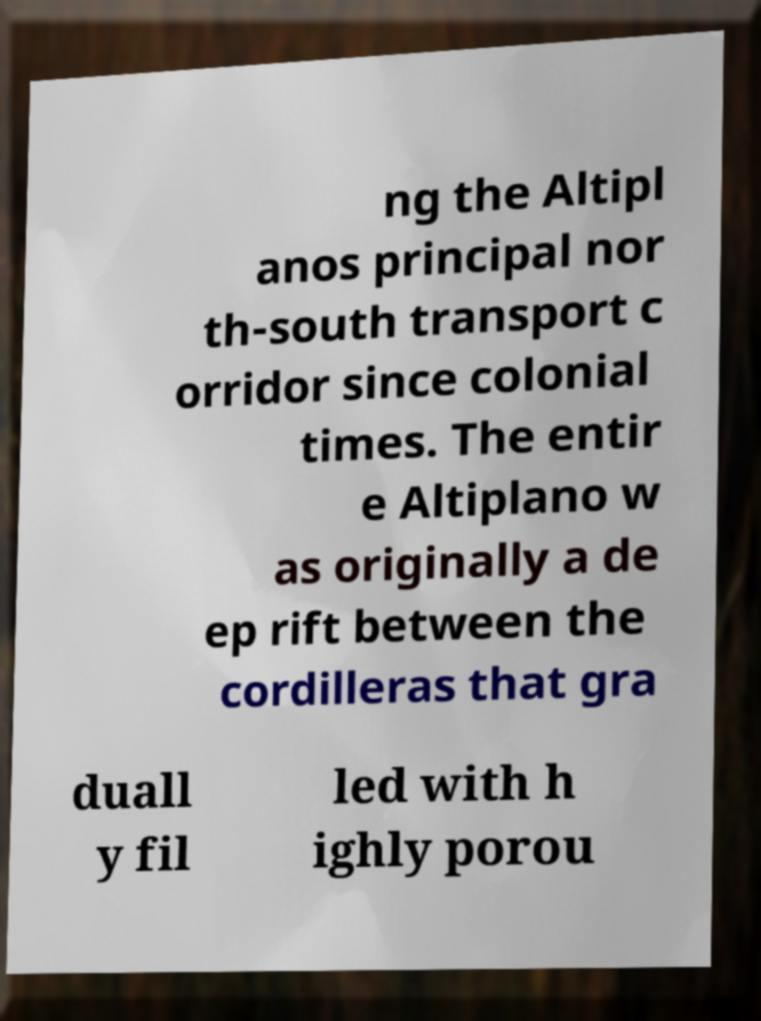Can you read and provide the text displayed in the image?This photo seems to have some interesting text. Can you extract and type it out for me? ng the Altipl anos principal nor th-south transport c orridor since colonial times. The entir e Altiplano w as originally a de ep rift between the cordilleras that gra duall y fil led with h ighly porou 